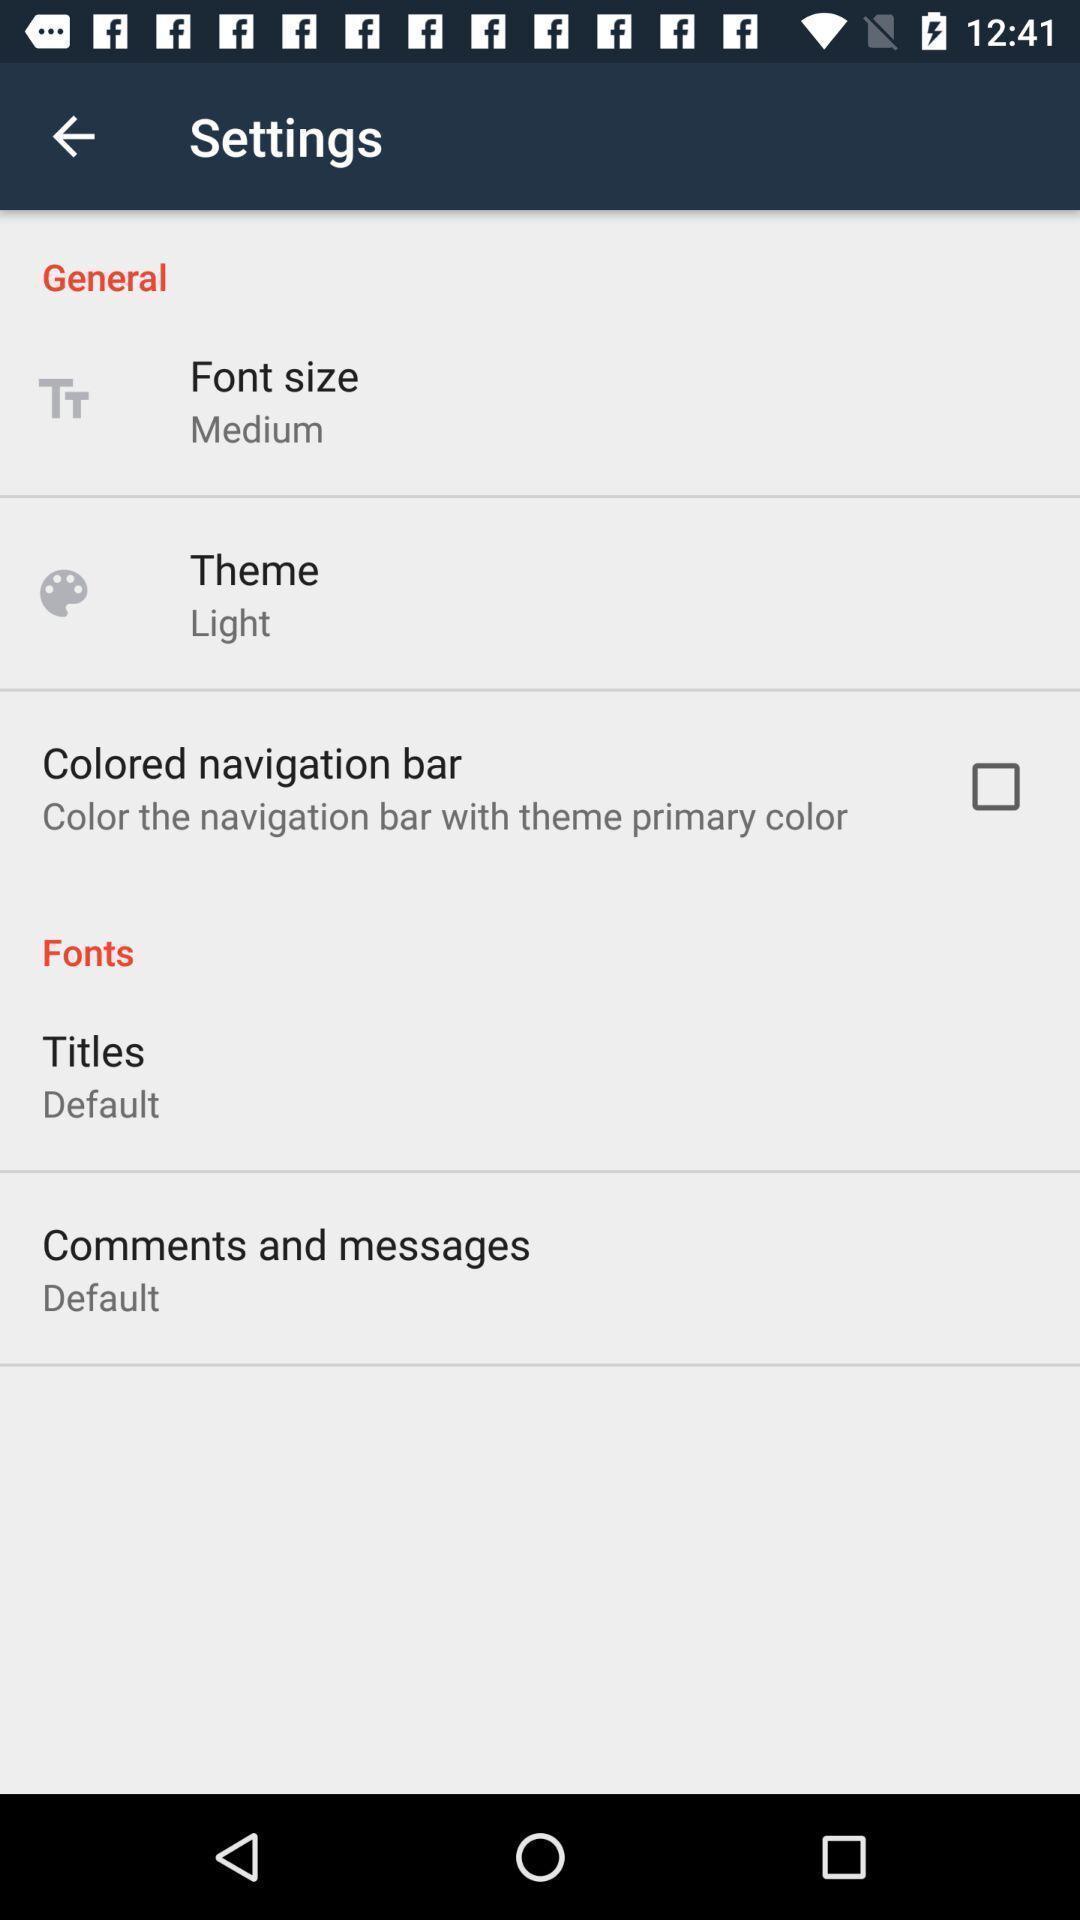Explain what's happening in this screen capture. Page showing settings options of mobile. 